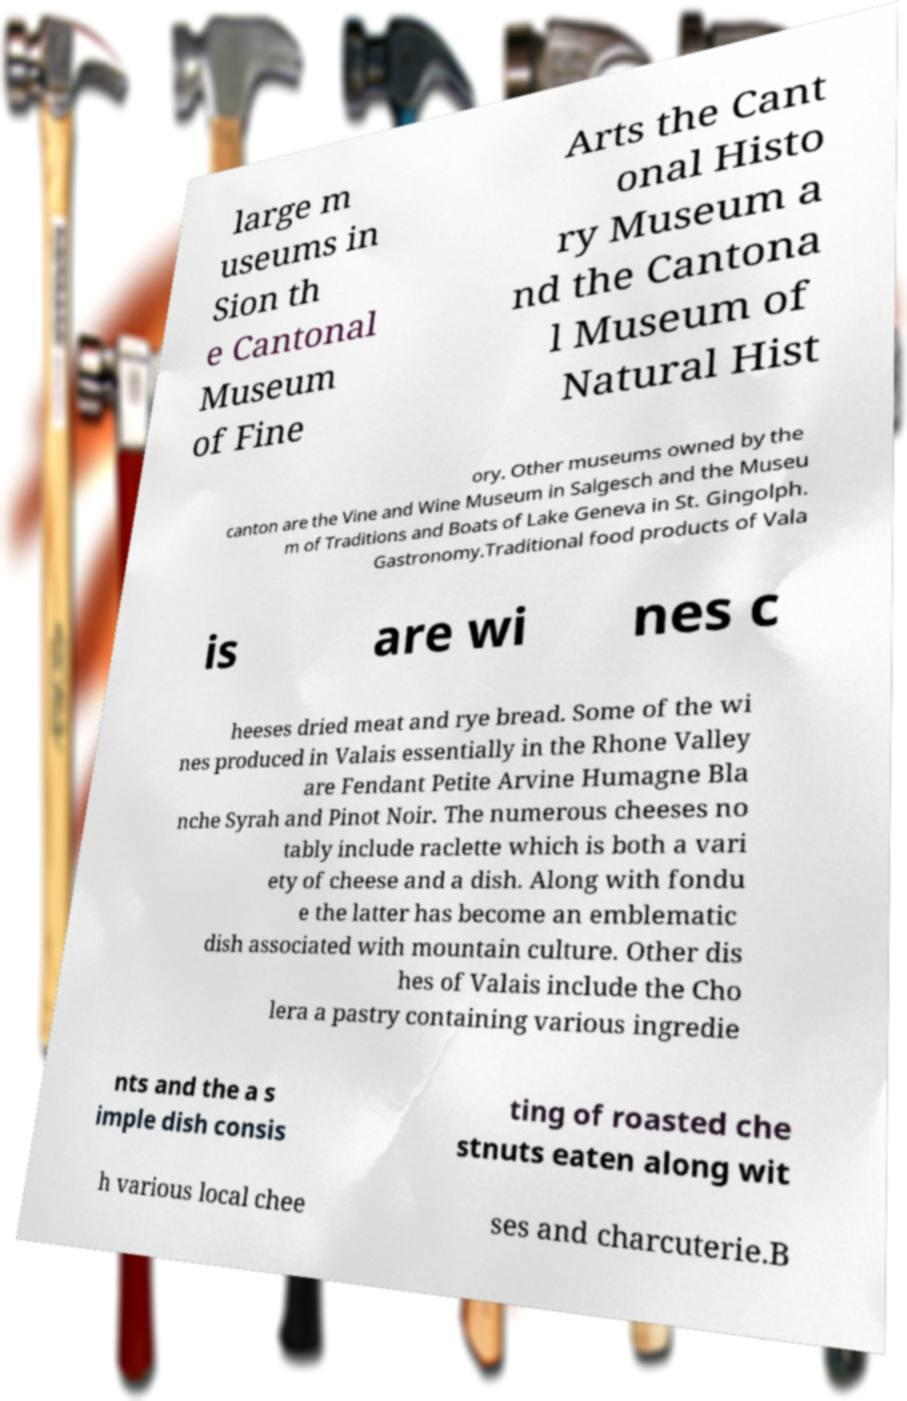There's text embedded in this image that I need extracted. Can you transcribe it verbatim? large m useums in Sion th e Cantonal Museum of Fine Arts the Cant onal Histo ry Museum a nd the Cantona l Museum of Natural Hist ory. Other museums owned by the canton are the Vine and Wine Museum in Salgesch and the Museu m of Traditions and Boats of Lake Geneva in St. Gingolph. Gastronomy.Traditional food products of Vala is are wi nes c heeses dried meat and rye bread. Some of the wi nes produced in Valais essentially in the Rhone Valley are Fendant Petite Arvine Humagne Bla nche Syrah and Pinot Noir. The numerous cheeses no tably include raclette which is both a vari ety of cheese and a dish. Along with fondu e the latter has become an emblematic dish associated with mountain culture. Other dis hes of Valais include the Cho lera a pastry containing various ingredie nts and the a s imple dish consis ting of roasted che stnuts eaten along wit h various local chee ses and charcuterie.B 